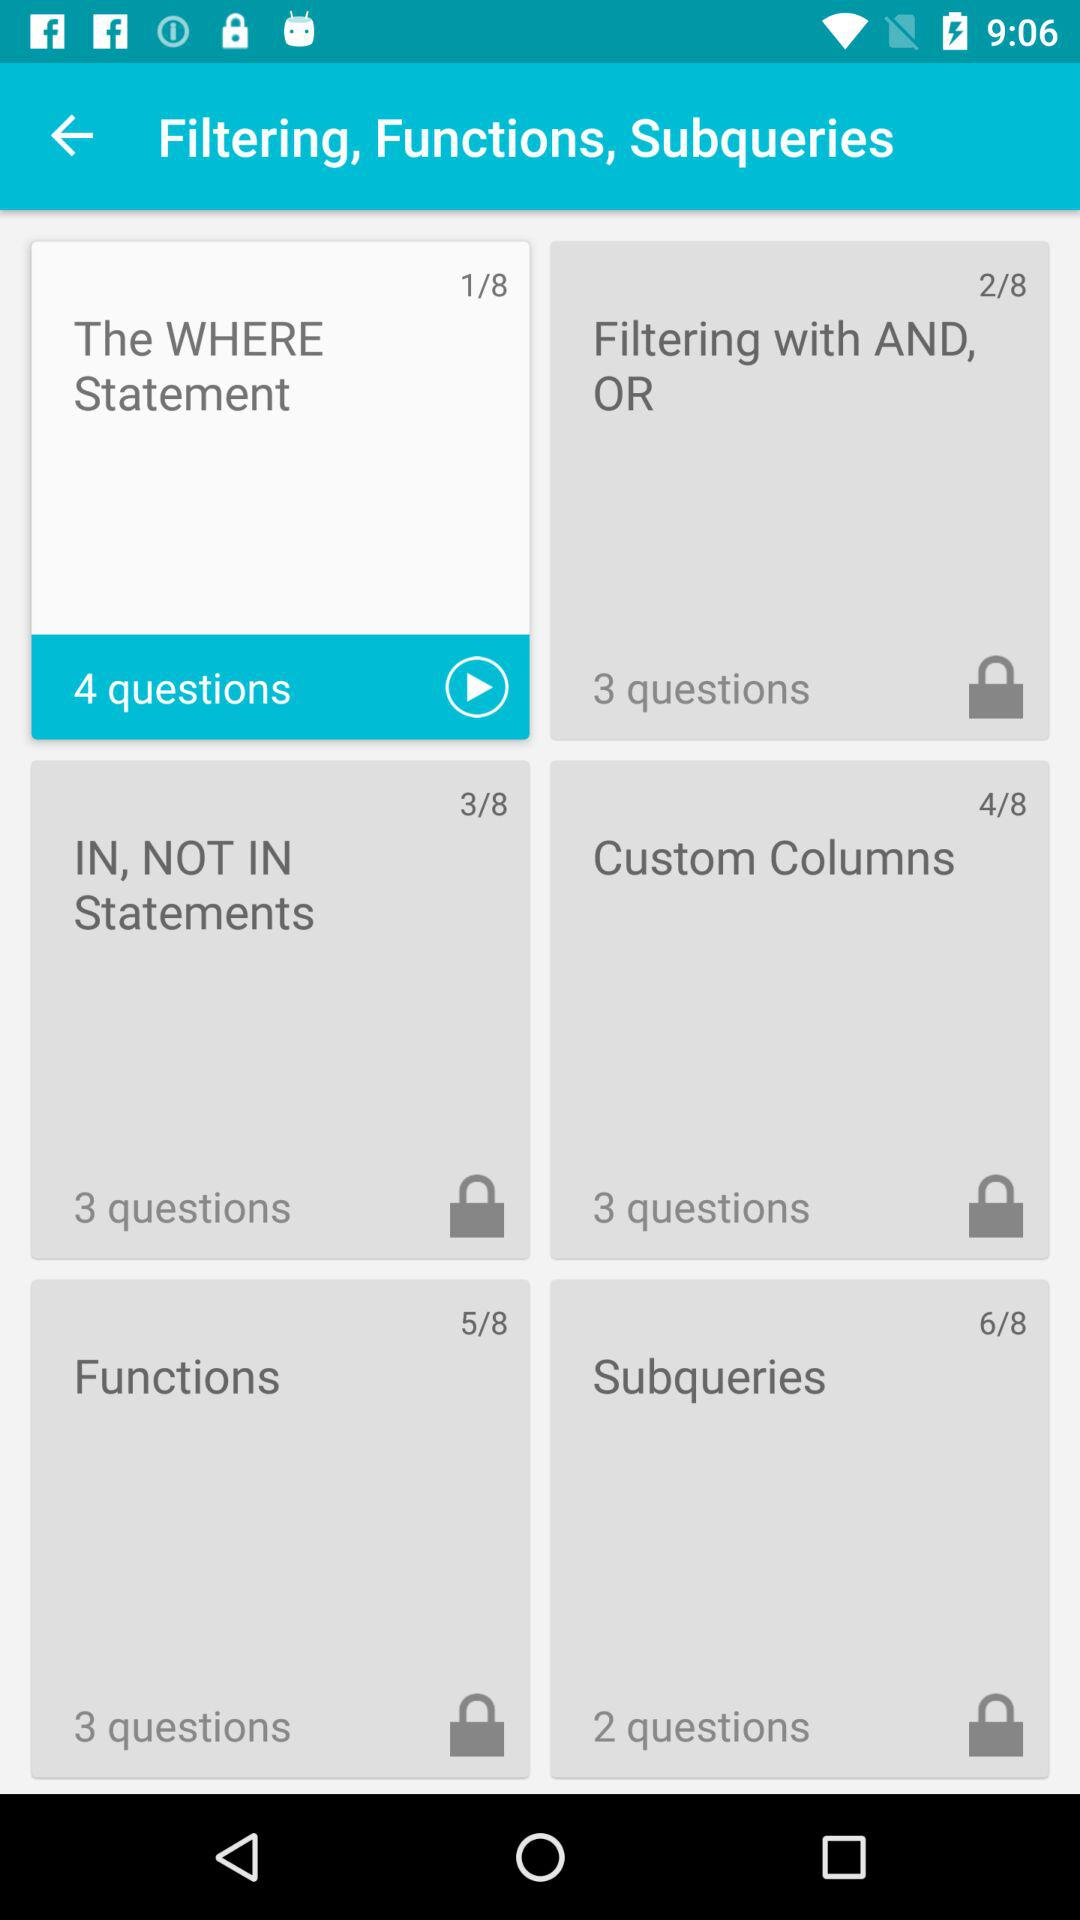How many questions are there about subqueries?
Answer the question using a single word or phrase. 2 